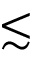<formula> <loc_0><loc_0><loc_500><loc_500>\lesssim</formula> 